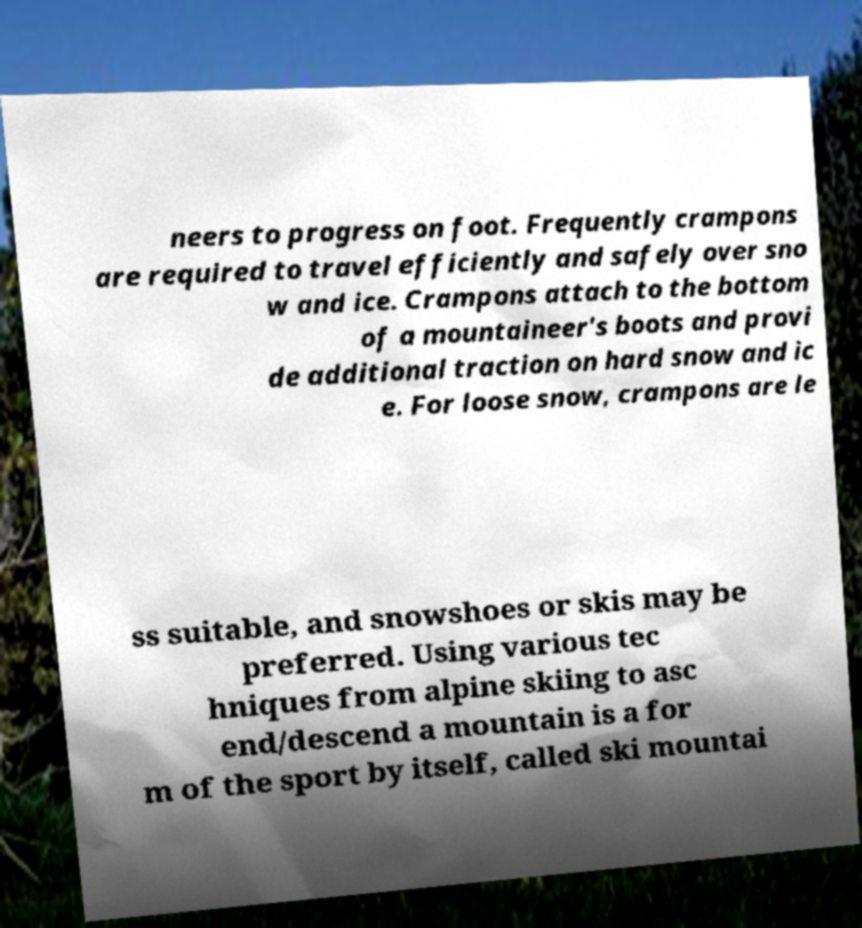Please read and relay the text visible in this image. What does it say? neers to progress on foot. Frequently crampons are required to travel efficiently and safely over sno w and ice. Crampons attach to the bottom of a mountaineer's boots and provi de additional traction on hard snow and ic e. For loose snow, crampons are le ss suitable, and snowshoes or skis may be preferred. Using various tec hniques from alpine skiing to asc end/descend a mountain is a for m of the sport by itself, called ski mountai 